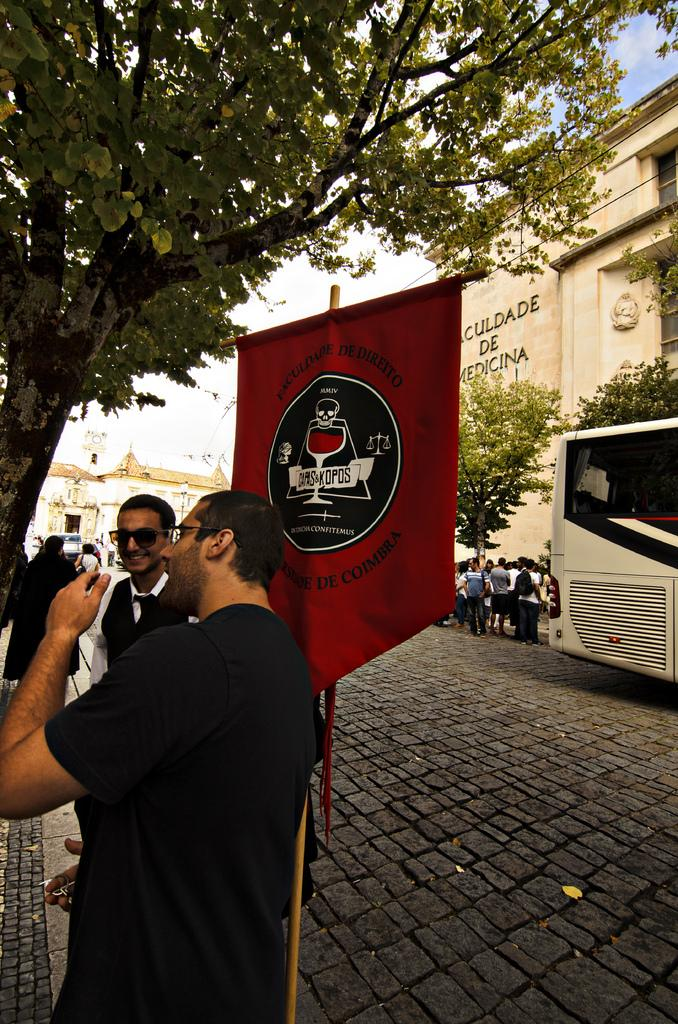Who or what can be seen in the image? There are people in the image. What type of structures are visible in the image? There are buildings in the image. What other natural elements can be seen in the image? There are trees in the image. What symbol or emblem is present in the image? There is a flag in the image. What mode of transportation is visible in the image? There is a vehicle in the image. What is visible in the background of the image? The sky is visible in the background of the image. What type of juice is being served at the table in the image? There is no table or juice present in the image. How many chairs can be seen in the image? There are no chairs visible in the image. 